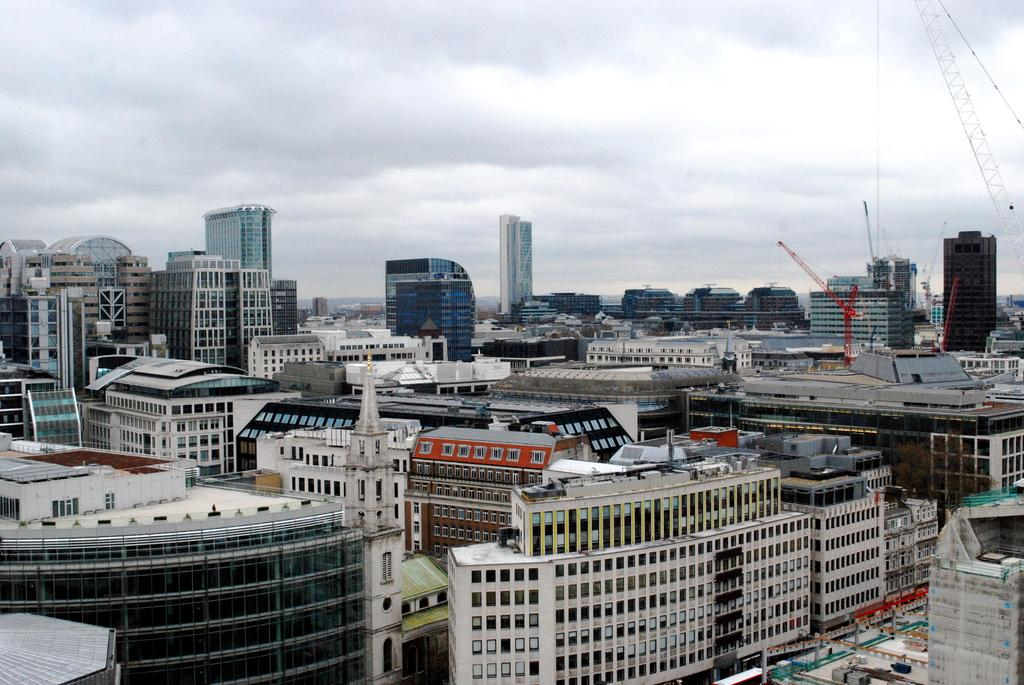What type of structures can be seen in the image? There are buildings in the image. What part of the natural environment is visible in the image? The sky is visible in the image. What can be observed in the sky? Clouds are present in the sky. Can you see any goldfish swimming in the ocean in the image? There is no ocean or goldfish present in the image; it features buildings and clouds in the sky. 